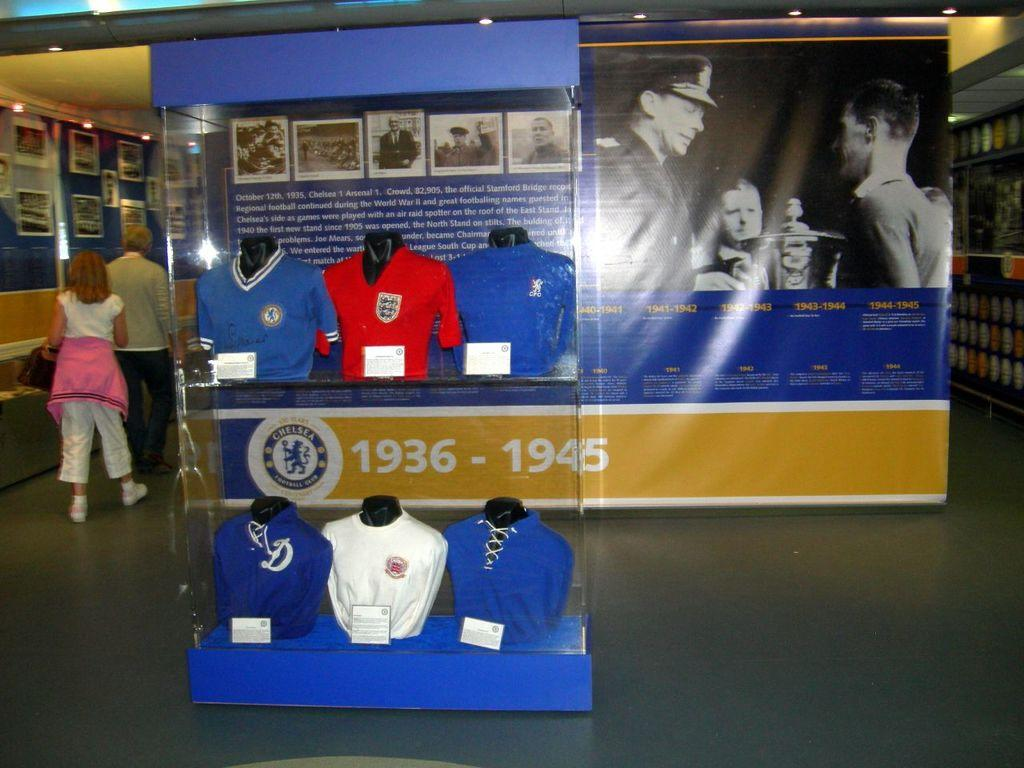<image>
Offer a succinct explanation of the picture presented. A sports display spans the years 1936 to 1945. 